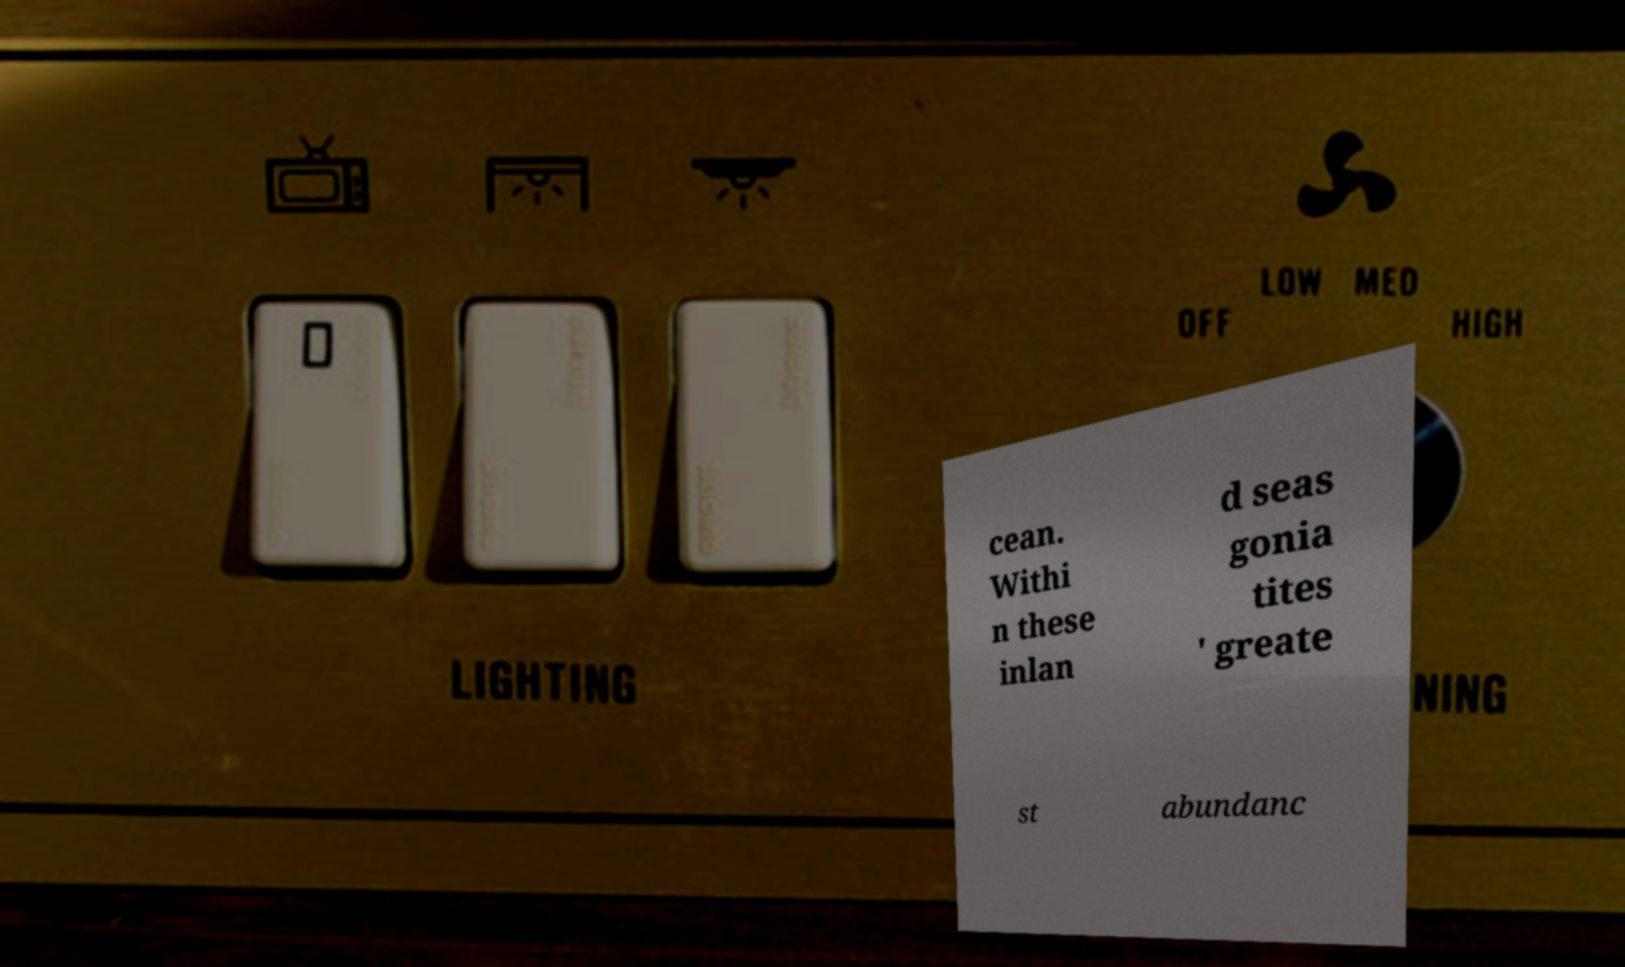Could you extract and type out the text from this image? cean. Withi n these inlan d seas gonia tites ' greate st abundanc 